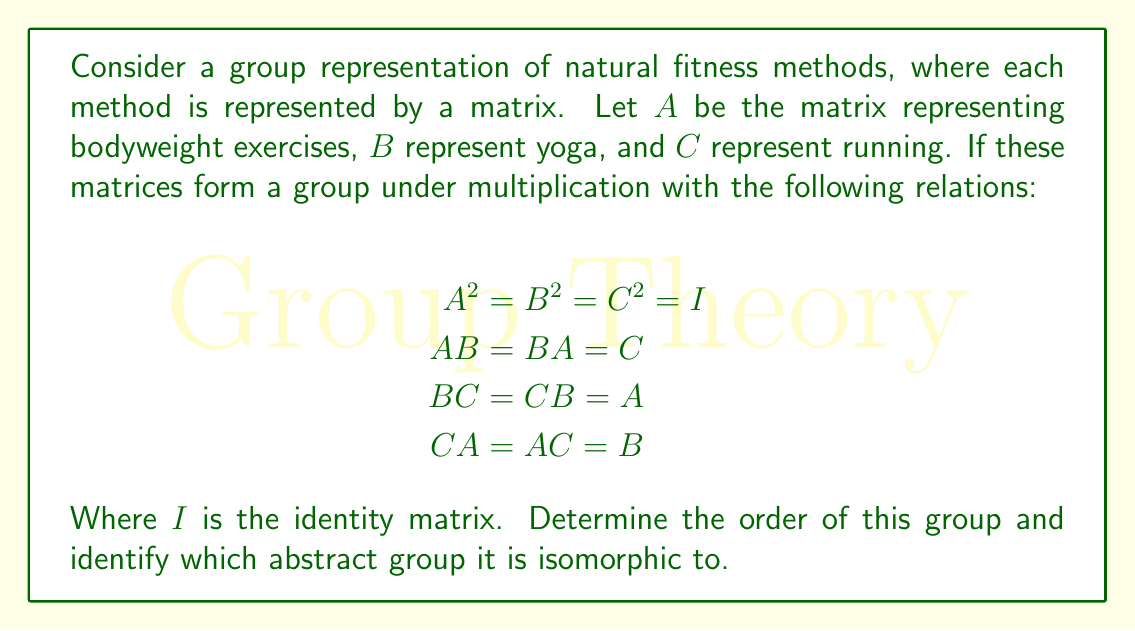Could you help me with this problem? Let's approach this step-by-step:

1) First, we need to identify all the elements of the group. From the given relations, we can see that the group contains:
   $I, A, B, C$

2) We can verify that these are all the elements by checking the closure property:
   - $A * A = I$
   - $B * B = I$
   - $C * C = I$
   - $A * B = C$
   - $B * C = A$
   - $C * A = B$

3) The number of elements in this group is 4, so the order of the group is 4.

4) Now, we need to identify which abstract group of order 4 this is isomorphic to. There are two possibilities:
   - Cyclic group $C_4$
   - Klein four-group $V_4$

5) In $C_4$, there is an element of order 4. However, in our group, all non-identity elements have order 2 ($A^2 = B^2 = C^2 = I$).

6) The Klein four-group $V_4$ is characterized by having three elements of order 2, besides the identity element. This matches our group structure.

7) Moreover, in $V_4$, the product of any two non-identity elements gives the third non-identity element, which is also true for our group ($AB = C$, $BC = A$, $CA = B$).

Therefore, this group is isomorphic to the Klein four-group $V_4$.
Answer: Klein four-group $V_4$ 